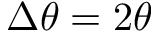<formula> <loc_0><loc_0><loc_500><loc_500>\Delta \theta = 2 \theta</formula> 